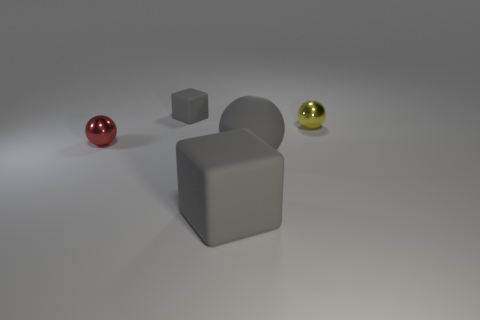Add 3 yellow spheres. How many objects exist? 8 Subtract all small balls. How many balls are left? 1 Subtract 0 blue blocks. How many objects are left? 5 Subtract all spheres. How many objects are left? 2 Subtract 1 balls. How many balls are left? 2 Subtract all yellow cubes. Subtract all green balls. How many cubes are left? 2 Subtract all purple balls. How many brown blocks are left? 0 Subtract all brown matte blocks. Subtract all big gray rubber cubes. How many objects are left? 4 Add 4 gray objects. How many gray objects are left? 7 Add 3 objects. How many objects exist? 8 